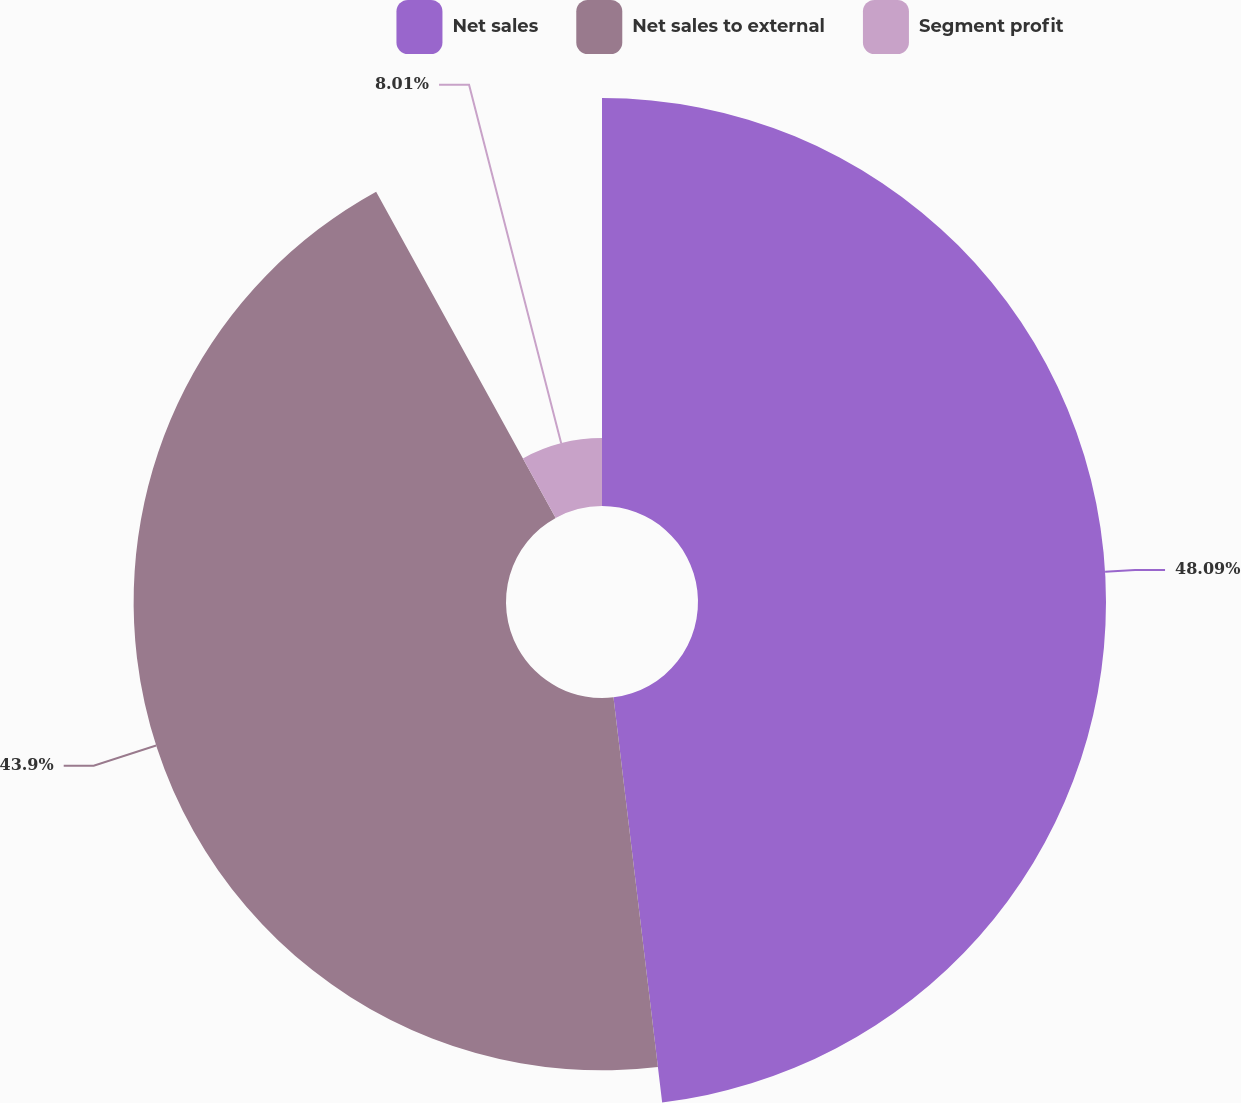Convert chart. <chart><loc_0><loc_0><loc_500><loc_500><pie_chart><fcel>Net sales<fcel>Net sales to external<fcel>Segment profit<nl><fcel>48.1%<fcel>43.9%<fcel>8.01%<nl></chart> 